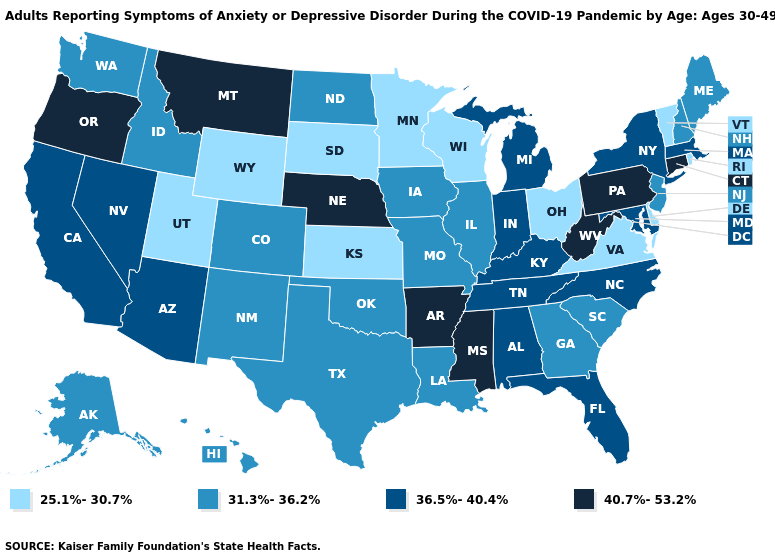Among the states that border Connecticut , does New York have the highest value?
Write a very short answer. Yes. Is the legend a continuous bar?
Concise answer only. No. Among the states that border Massachusetts , does Connecticut have the highest value?
Give a very brief answer. Yes. Does Florida have the same value as Idaho?
Answer briefly. No. What is the value of California?
Answer briefly. 36.5%-40.4%. What is the lowest value in states that border Kansas?
Write a very short answer. 31.3%-36.2%. Does the map have missing data?
Give a very brief answer. No. Name the states that have a value in the range 36.5%-40.4%?
Answer briefly. Alabama, Arizona, California, Florida, Indiana, Kentucky, Maryland, Massachusetts, Michigan, Nevada, New York, North Carolina, Tennessee. What is the lowest value in the USA?
Concise answer only. 25.1%-30.7%. Name the states that have a value in the range 40.7%-53.2%?
Give a very brief answer. Arkansas, Connecticut, Mississippi, Montana, Nebraska, Oregon, Pennsylvania, West Virginia. Which states have the highest value in the USA?
Write a very short answer. Arkansas, Connecticut, Mississippi, Montana, Nebraska, Oregon, Pennsylvania, West Virginia. What is the value of Hawaii?
Quick response, please. 31.3%-36.2%. Name the states that have a value in the range 25.1%-30.7%?
Be succinct. Delaware, Kansas, Minnesota, Ohio, Rhode Island, South Dakota, Utah, Vermont, Virginia, Wisconsin, Wyoming. What is the highest value in the South ?
Write a very short answer. 40.7%-53.2%. What is the value of Vermont?
Answer briefly. 25.1%-30.7%. 